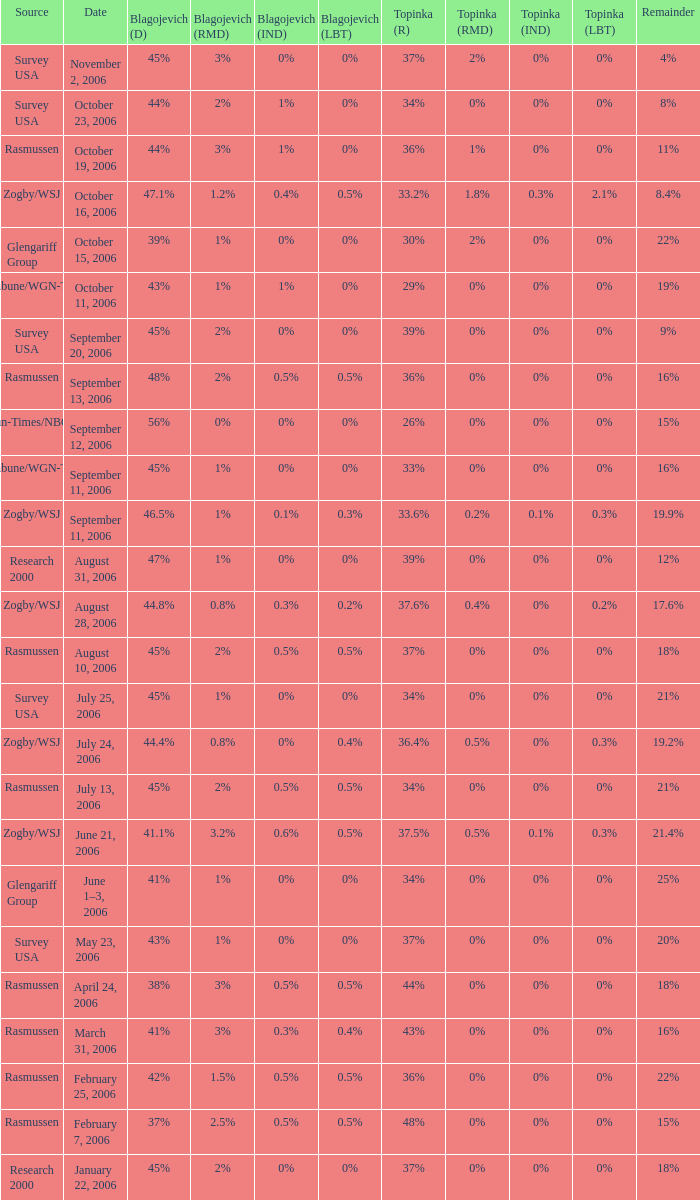Which Blagojevich (D) has a Source of zogby/wsj, and a Date of october 16, 2006? 47.1%. 